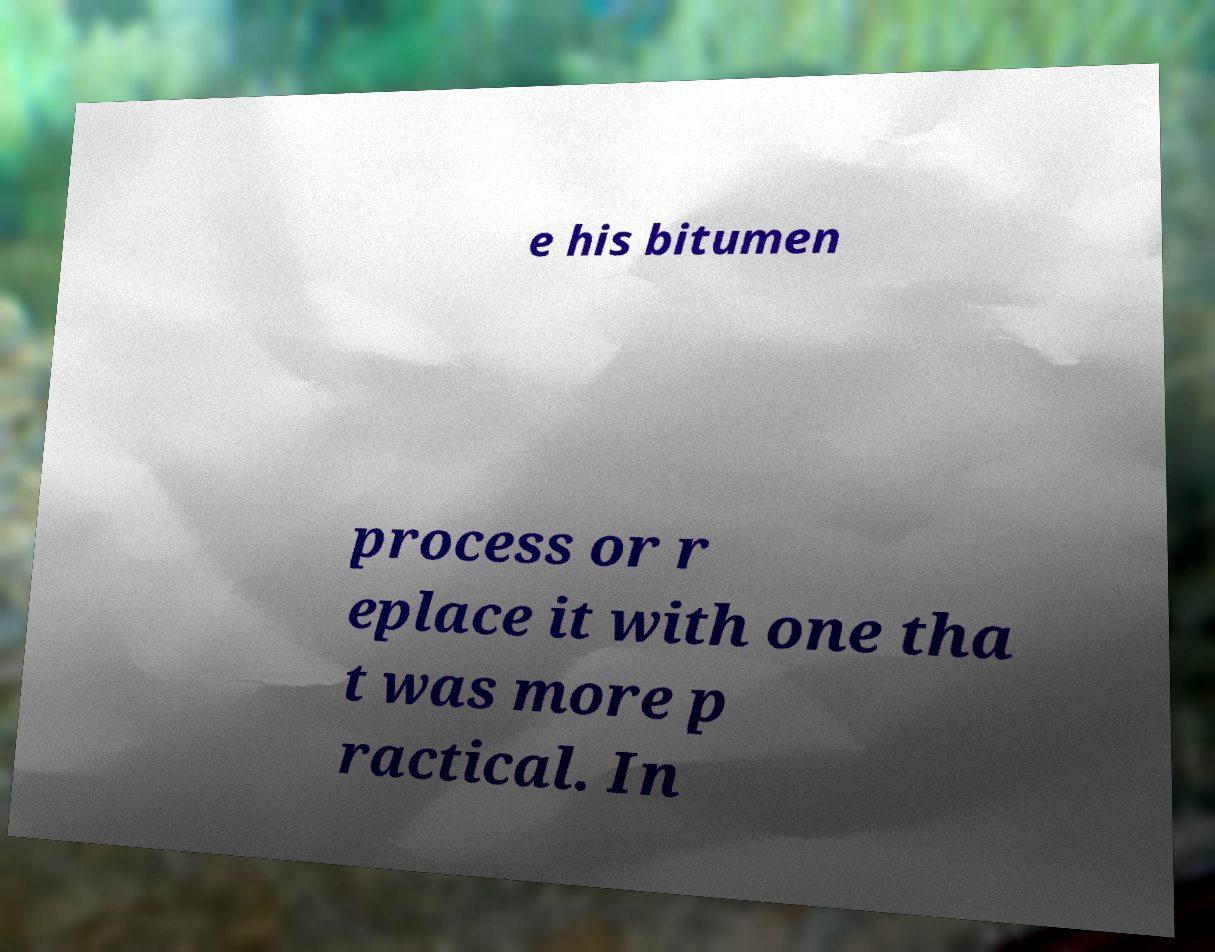Please read and relay the text visible in this image. What does it say? e his bitumen process or r eplace it with one tha t was more p ractical. In 